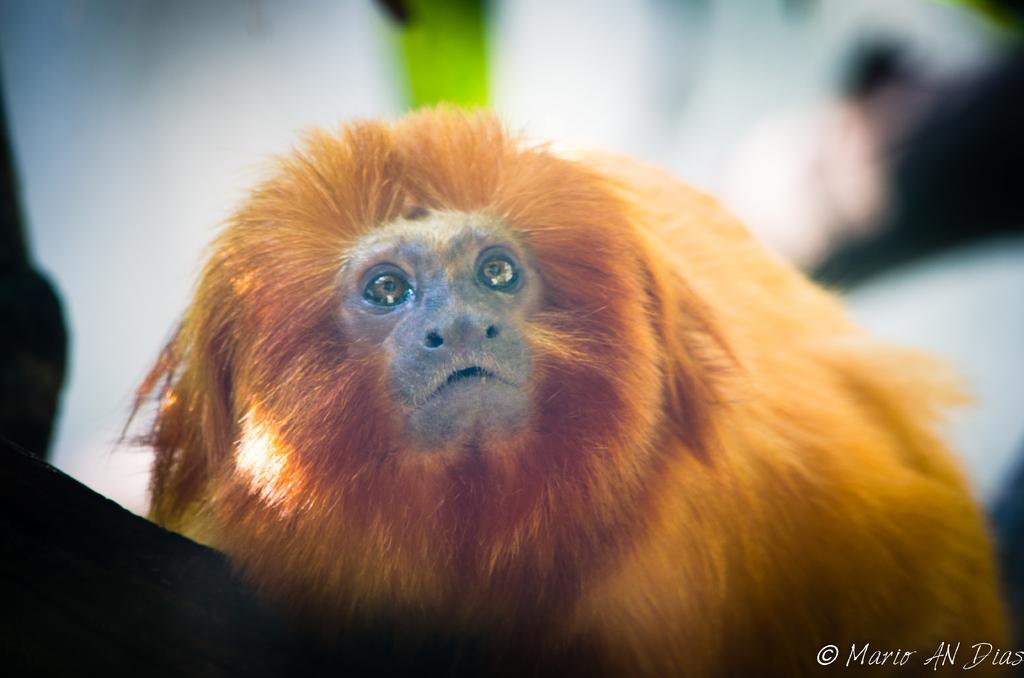How would you summarize this image in a sentence or two? In this image I can see a monkey which is in brown color and I can see blurred background. 